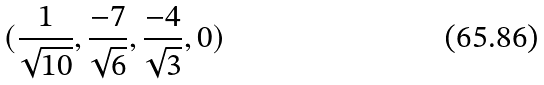<formula> <loc_0><loc_0><loc_500><loc_500>( \frac { 1 } { \sqrt { 1 0 } } , \frac { - 7 } { \sqrt { 6 } } , \frac { - 4 } { \sqrt { 3 } } , 0 )</formula> 